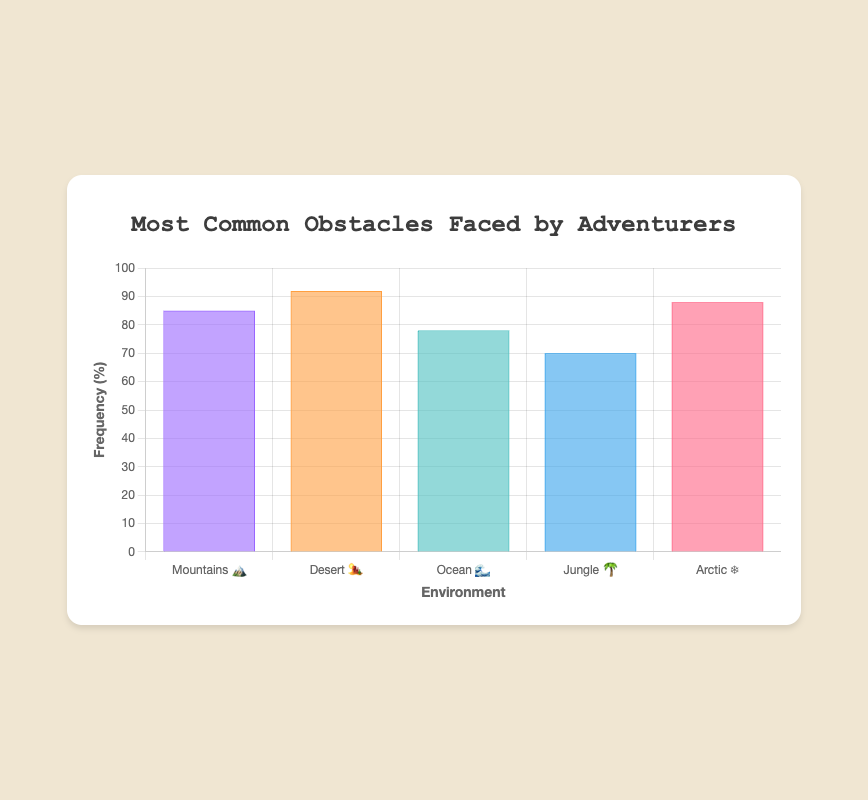What's the title of the figure? The title of the figure is displayed at the top and reads "Most Common Obstacles Faced by Adventurers".
Answer: Most Common Obstacles Faced by Adventurers What environments are included in the chart? The environments listed on the x-axis are Mountains, Desert, Ocean, Jungle, and Arctic, each accompanied by respective emojis.
Answer: Mountains, Desert, Ocean, Jungle, Arctic Which environment has the highest frequency of obstacles? By looking at the bar heights and frequency values, the Desert (🏜️) has the highest frequency at 92%.
Answer: Desert What obstacle is most common in the mountains? By referencing the tooltip or dataset, the most common obstacle in the Mountains (🏔️) is Altitude sickness.
Answer: Altitude sickness How does the frequency of obstacles in the Arctic compare to the Ocean? The Arctic (❄️) has a frequency of 88%, and the Ocean (🌊) has a frequency of 78%, so the Arctic has a higher frequency.
Answer: Arctic What is the average frequency of obstacles across all environments? Sum the frequency values (85 + 92 + 78 + 70 + 88) to get 413, then divide by the number of environments, which is 5. The average frequency is 413/5.
Answer: 82.6 Which two environments have the closest frequency of obstacles? Comparing the values, the Mountains (85%) and the Arctic (88%) have the closest frequencies. The difference is 3%.
Answer: Mountains and Arctic What is the color of the bar representing the ocean environment? The color of the bar representing the Ocean (🌊) is a shade of light blue or teal.
Answer: Light blue/Teal Which obstacle is represented with the lowest frequency and in which environment does it occur? By checking the frequency values, the Jungle (🌴) has the lowest obstacle frequency of 70%, and the obstacle is Predators.
Answer: Predators in Jungle If we sum the frequencies of the Desert and Arctic environments, what value do we get? The frequencies for the Desert (92%) and Arctic (88%) sum up to 180%.
Answer: 180 